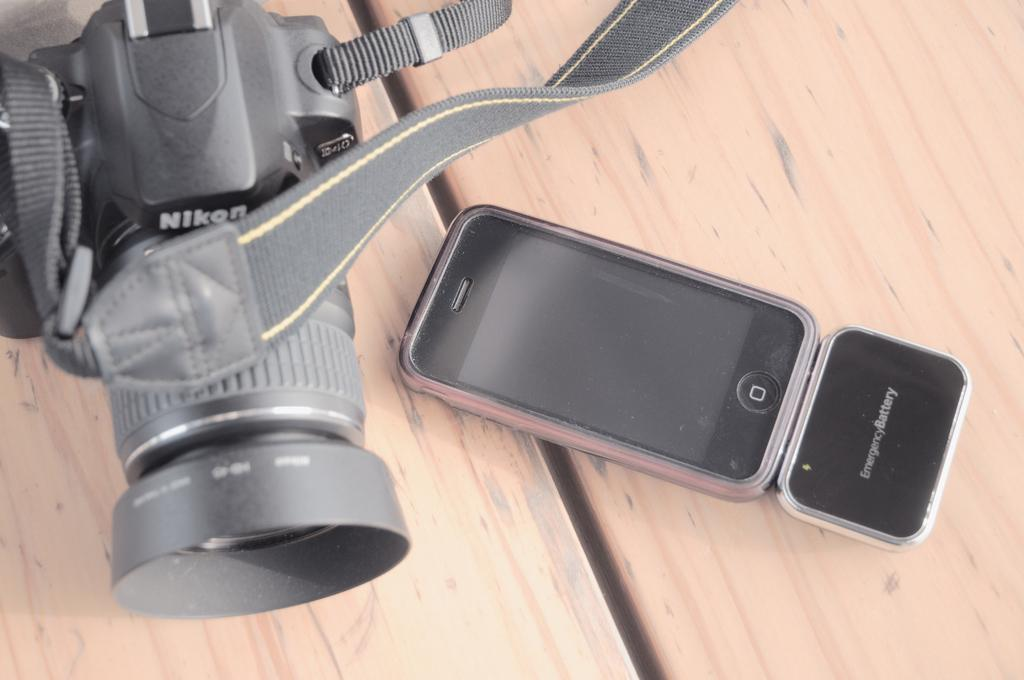What device is located on the left side of the image? There is a camera on the left side of the image. What color is the camera in the image? The camera is black in color. What other electronic device is present in the image? There is an iPhone in the image. What type of comb is used to style the camera in the image? There is no comb present in the image, and the camera does not require styling. 